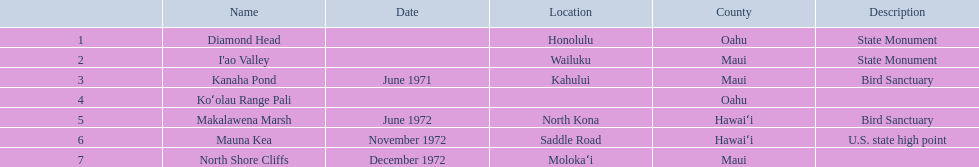What are the different landmark names? Diamond Head, I'ao Valley, Kanaha Pond, Koʻolau Range Pali, Makalawena Marsh, Mauna Kea, North Shore Cliffs. Can you give me this table in json format? {'header': ['', 'Name', 'Date', 'Location', 'County', 'Description'], 'rows': [['1', 'Diamond Head', '', 'Honolulu', 'Oahu', 'State Monument'], ['2', "I'ao Valley", '', 'Wailuku', 'Maui', 'State Monument'], ['3', 'Kanaha Pond', 'June 1971', 'Kahului', 'Maui', 'Bird Sanctuary'], ['4', 'Koʻolau Range Pali', '', '', 'Oahu', ''], ['5', 'Makalawena Marsh', 'June 1972', 'North Kona', 'Hawaiʻi', 'Bird Sanctuary'], ['6', 'Mauna Kea', 'November 1972', 'Saddle Road', 'Hawaiʻi', 'U.S. state high point'], ['7', 'North Shore Cliffs', 'December 1972', 'Molokaʻi', 'Maui', '']]} Which of these is located in the county hawai`i? Makalawena Marsh, Mauna Kea. Which of these is not mauna kea? Makalawena Marsh. 